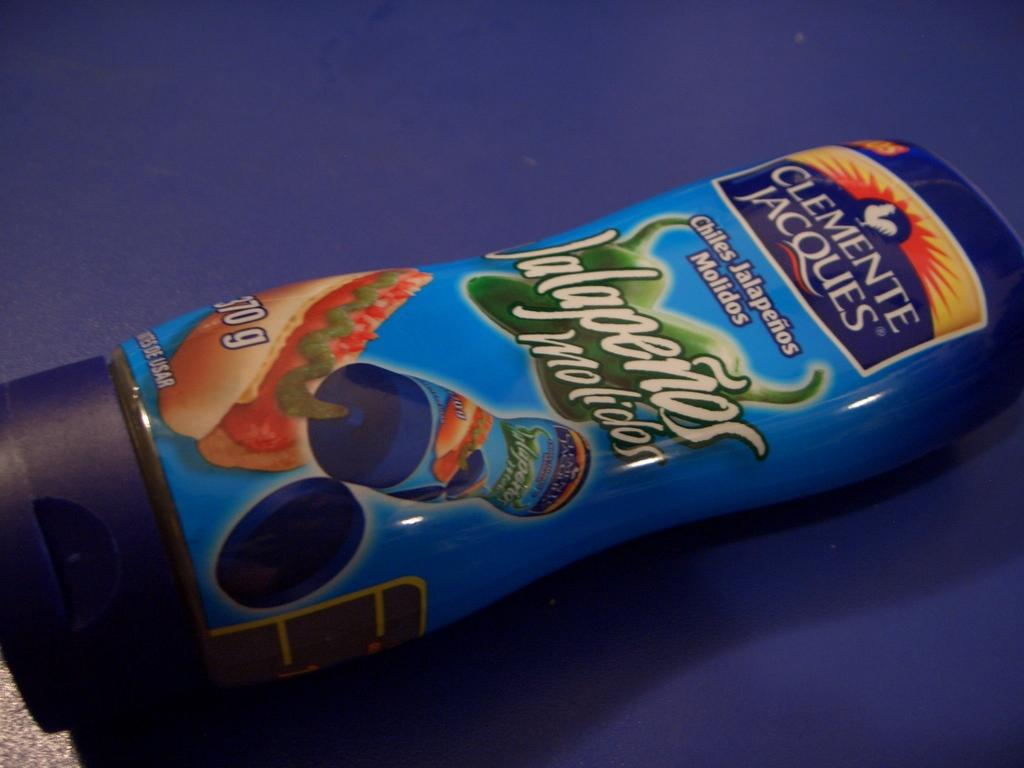Provide a one-sentence caption for the provided image. A blue container of Jalapenos sauce made by Clemente Jacques. 